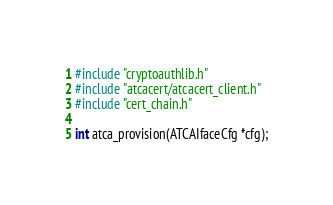<code> <loc_0><loc_0><loc_500><loc_500><_C_>#include "cryptoauthlib.h"
#include "atcacert/atcacert_client.h"
#include "cert_chain.h"

int atca_provision(ATCAIfaceCfg *cfg);</code> 